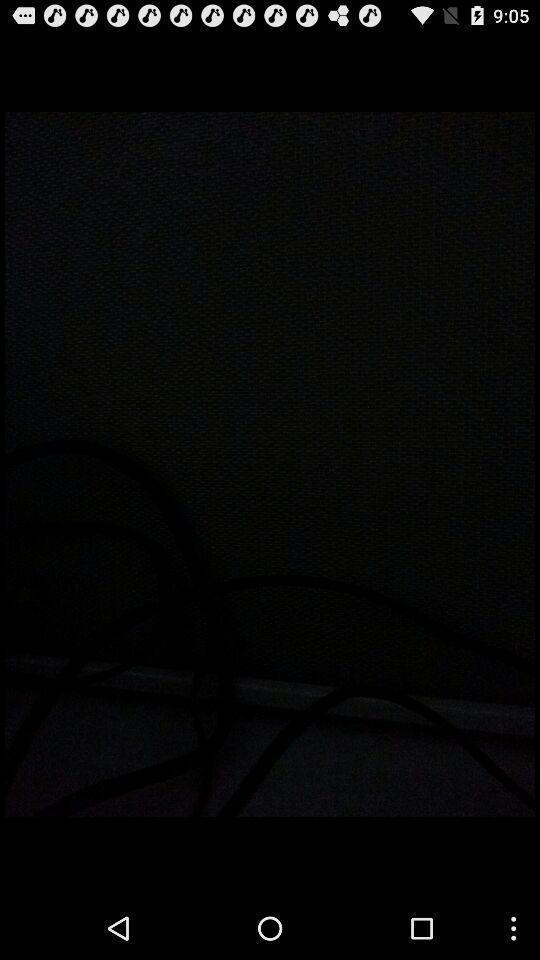Describe this image in words. Screen showing a blank page. 